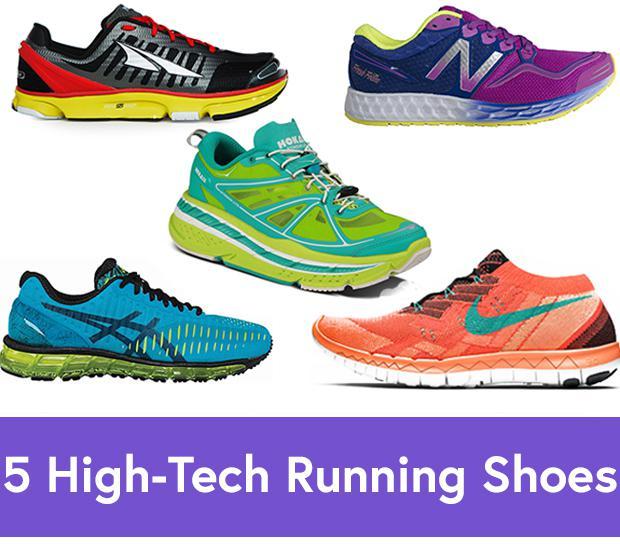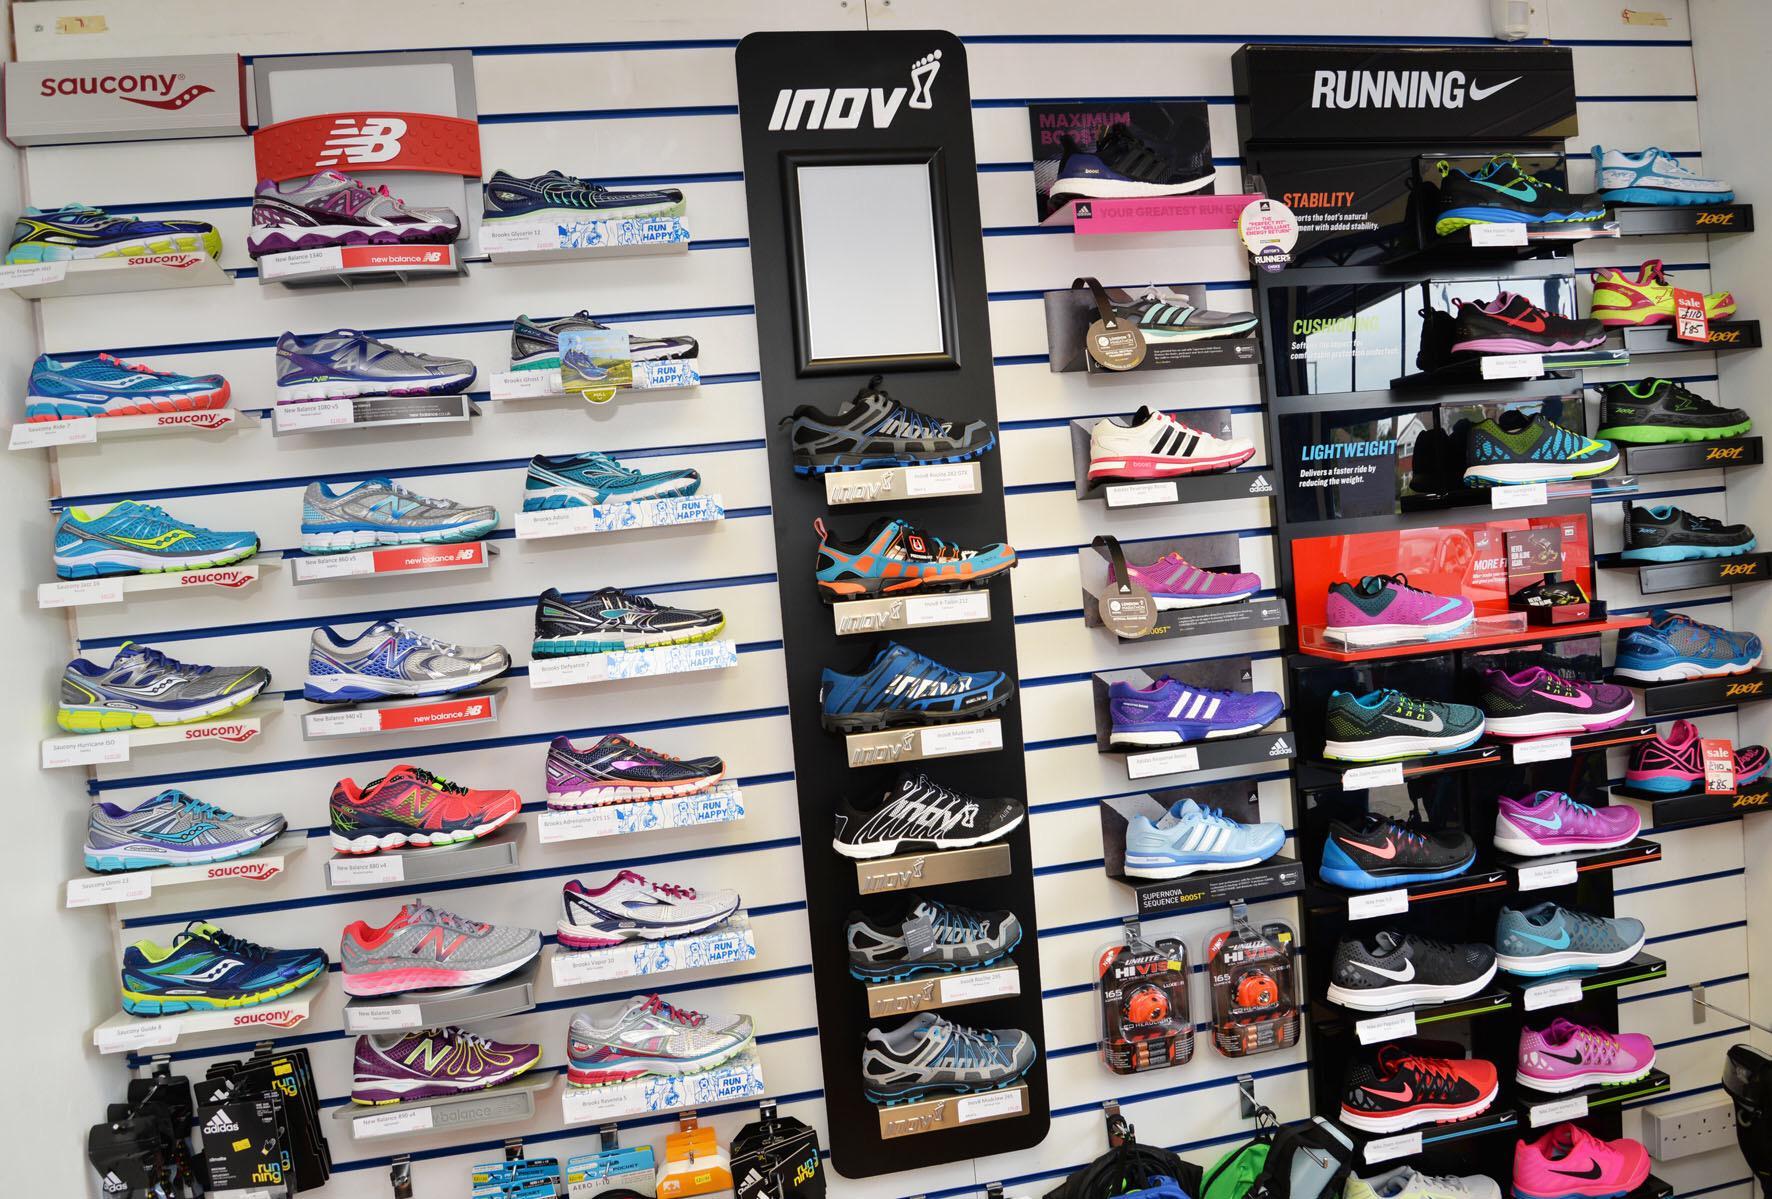The first image is the image on the left, the second image is the image on the right. Evaluate the accuracy of this statement regarding the images: "One image shows different sneakers which are not displayed in rows on shelves.". Is it true? Answer yes or no. Yes. The first image is the image on the left, the second image is the image on the right. Examine the images to the left and right. Is the description "The shoes in one of the images are not sitting on the store racks." accurate? Answer yes or no. Yes. 